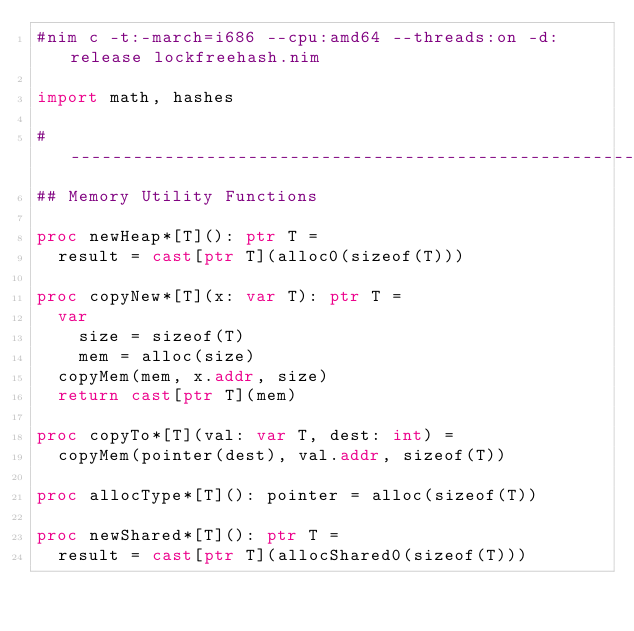<code> <loc_0><loc_0><loc_500><loc_500><_Nim_>#nim c -t:-march=i686 --cpu:amd64 --threads:on -d:release lockfreehash.nim

import math, hashes

#------------------------------------------------------------------------------
## Memory Utility Functions

proc newHeap*[T](): ptr T =
  result = cast[ptr T](alloc0(sizeof(T)))

proc copyNew*[T](x: var T): ptr T =
  var
    size = sizeof(T)
    mem = alloc(size)
  copyMem(mem, x.addr, size)
  return cast[ptr T](mem)

proc copyTo*[T](val: var T, dest: int) =
  copyMem(pointer(dest), val.addr, sizeof(T))

proc allocType*[T](): pointer = alloc(sizeof(T))

proc newShared*[T](): ptr T =
  result = cast[ptr T](allocShared0(sizeof(T)))
</code> 